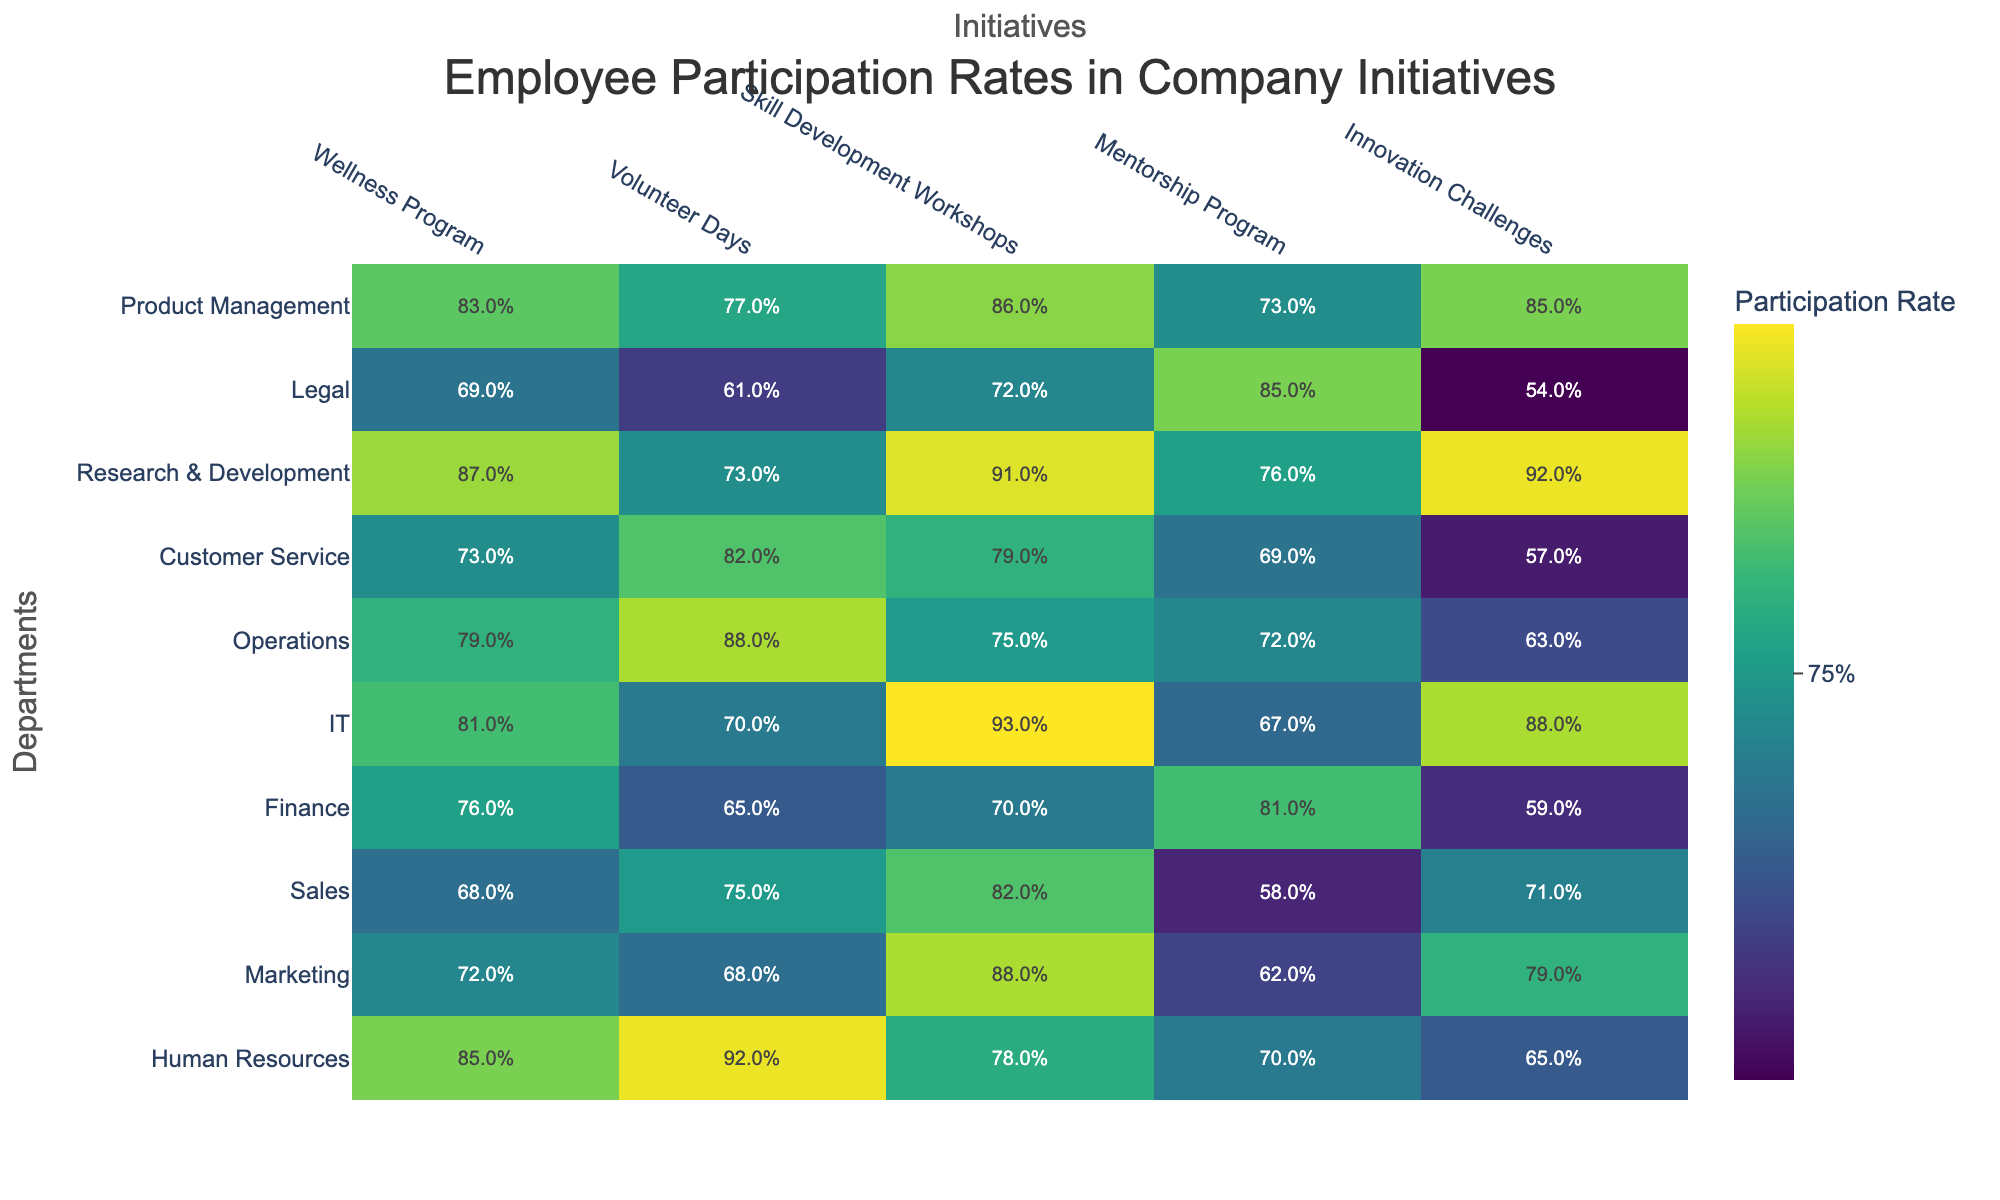What is the highest participation rate in the Wellness Program? By looking at the table, the highest percentage in the Wellness Program is found in the Human Resources department, with a participation rate of 85%.
Answer: 85% Which department has the lowest participation in the Volunteer Days initiative? The department with the lowest percentage participation in Volunteer Days is Legal, with a rate of 61%.
Answer: 61% What is the average participation rate across all departments for Skill Development Workshops? To find the average, first sum the participation rates for Skill Development Workshops: (78 + 88 + 82 + 70 + 93 + 75 + 79 + 91 + 72 + 86) = 820. There are 10 departments, so the average is 820/10 = 82%.
Answer: 82% How do the participation rates in the Innovation Challenges compare between IT and Finance? IT has a participation rate of 88%, while Finance has a rate of 59%. The difference is 88% - 59% = 29%. This shows that IT has significantly higher participation in Innovation Challenges than Finance.
Answer: 29% Is the participation rate for the Mentorship Program in the Marketing department above 70%? The Marketing department has a participation rate of 62% in the Mentorship Program, which is below 70%.
Answer: No Which department has the highest participation in Skill Development Workshops, and what is the percentage? The department with the highest rate in Skill Development Workshops is IT, with a participation rate of 93%.
Answer: 93% What is the difference in participation rates between the highest and lowest rates for the Wellness Program? The highest participation in the Wellness Program is 85% (Human Resources) and the lowest is 69% (Legal). The difference is 85% - 69% = 16%.
Answer: 16% How many departments have a participation rate over 80% for Volunteer Days? The departments with over 80% participation in Volunteer Days are Human Resources (92%), IT (70%), Operations (88%), and Customer Service (82%), totaling 4 departments.
Answer: 5 Is there a department where the participation rate in all initiatives is above 75%? Yes, the Research & Development department has participation rates above 75% in all initiatives: 87% (Wellness Program), 73% (Volunteer Days), 91% (Skill Development Workshops), 76% (Mentorship Program), and 92% (Innovation Challenges).
Answer: Yes Which initiative has the lowest overall participation rate across all departments? To determine the lowest overall participation rate, we review each initiative's rates: Wellness Program (highest is 85%), Volunteer Days (highest is 92%), Skill Development Workshops (highest is 93%), Mentorship Program (highest is 85%), Innovation Challenges (highest is 88%). The lowest overall participation rate is for Legal in Innovation Challenges, at 54%.
Answer: Innovation Challenges 